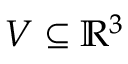Convert formula to latex. <formula><loc_0><loc_0><loc_500><loc_500>V \subseteq \mathbb { R } ^ { 3 }</formula> 